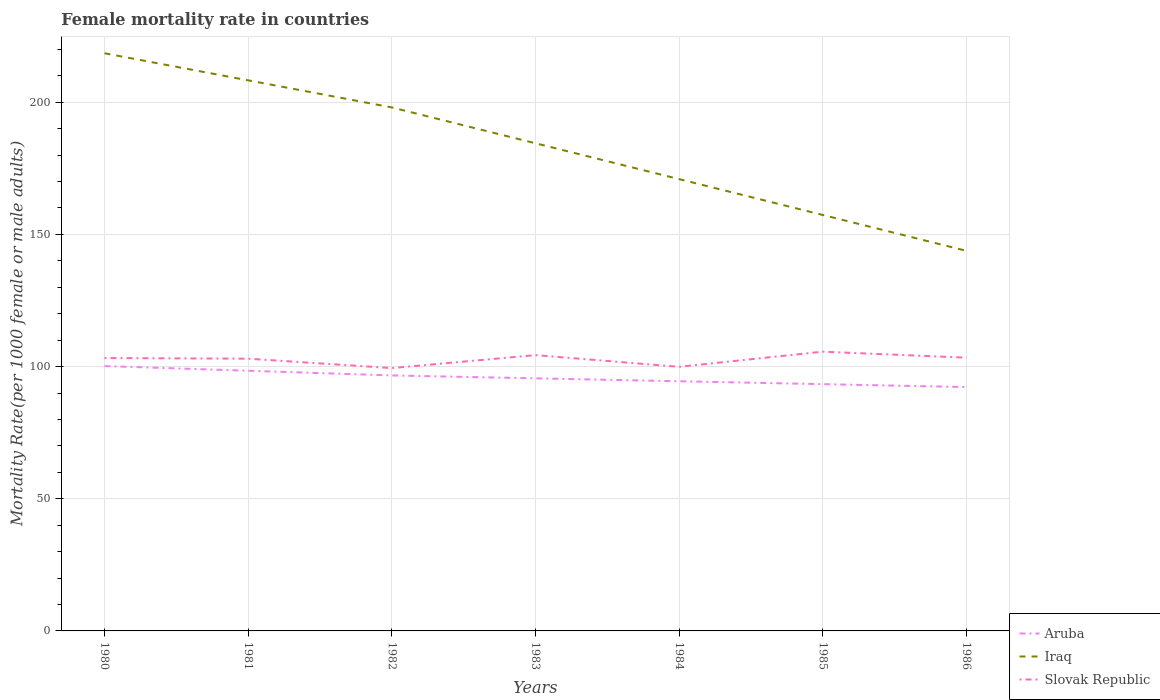How many different coloured lines are there?
Offer a terse response. 3. Does the line corresponding to Aruba intersect with the line corresponding to Slovak Republic?
Ensure brevity in your answer.  No. Across all years, what is the maximum female mortality rate in Iraq?
Offer a very short reply. 143.8. What is the total female mortality rate in Slovak Republic in the graph?
Provide a succinct answer. -0.48. What is the difference between the highest and the second highest female mortality rate in Iraq?
Your answer should be compact. 74.74. What is the difference between the highest and the lowest female mortality rate in Aruba?
Your answer should be compact. 3. What is the difference between two consecutive major ticks on the Y-axis?
Your response must be concise. 50. Are the values on the major ticks of Y-axis written in scientific E-notation?
Your response must be concise. No. Does the graph contain grids?
Offer a terse response. Yes. Where does the legend appear in the graph?
Keep it short and to the point. Bottom right. What is the title of the graph?
Offer a terse response. Female mortality rate in countries. Does "Iraq" appear as one of the legend labels in the graph?
Your answer should be very brief. Yes. What is the label or title of the Y-axis?
Your answer should be compact. Mortality Rate(per 1000 female or male adults). What is the Mortality Rate(per 1000 female or male adults) of Aruba in 1980?
Offer a terse response. 100.2. What is the Mortality Rate(per 1000 female or male adults) of Iraq in 1980?
Make the answer very short. 218.54. What is the Mortality Rate(per 1000 female or male adults) in Slovak Republic in 1980?
Offer a very short reply. 103.24. What is the Mortality Rate(per 1000 female or male adults) of Aruba in 1981?
Your response must be concise. 98.43. What is the Mortality Rate(per 1000 female or male adults) of Iraq in 1981?
Offer a terse response. 208.29. What is the Mortality Rate(per 1000 female or male adults) in Slovak Republic in 1981?
Provide a short and direct response. 102.99. What is the Mortality Rate(per 1000 female or male adults) in Aruba in 1982?
Give a very brief answer. 96.66. What is the Mortality Rate(per 1000 female or male adults) of Iraq in 1982?
Your answer should be very brief. 198.05. What is the Mortality Rate(per 1000 female or male adults) of Slovak Republic in 1982?
Your answer should be very brief. 99.44. What is the Mortality Rate(per 1000 female or male adults) of Aruba in 1983?
Your response must be concise. 95.56. What is the Mortality Rate(per 1000 female or male adults) in Iraq in 1983?
Offer a terse response. 184.49. What is the Mortality Rate(per 1000 female or male adults) in Slovak Republic in 1983?
Provide a succinct answer. 104.34. What is the Mortality Rate(per 1000 female or male adults) of Aruba in 1984?
Ensure brevity in your answer.  94.46. What is the Mortality Rate(per 1000 female or male adults) in Iraq in 1984?
Your response must be concise. 170.93. What is the Mortality Rate(per 1000 female or male adults) of Slovak Republic in 1984?
Provide a short and direct response. 99.92. What is the Mortality Rate(per 1000 female or male adults) in Aruba in 1985?
Your response must be concise. 93.36. What is the Mortality Rate(per 1000 female or male adults) of Iraq in 1985?
Give a very brief answer. 157.36. What is the Mortality Rate(per 1000 female or male adults) of Slovak Republic in 1985?
Keep it short and to the point. 105.65. What is the Mortality Rate(per 1000 female or male adults) of Aruba in 1986?
Provide a succinct answer. 92.25. What is the Mortality Rate(per 1000 female or male adults) of Iraq in 1986?
Give a very brief answer. 143.8. What is the Mortality Rate(per 1000 female or male adults) in Slovak Republic in 1986?
Offer a very short reply. 103.38. Across all years, what is the maximum Mortality Rate(per 1000 female or male adults) in Aruba?
Give a very brief answer. 100.2. Across all years, what is the maximum Mortality Rate(per 1000 female or male adults) of Iraq?
Your answer should be compact. 218.54. Across all years, what is the maximum Mortality Rate(per 1000 female or male adults) of Slovak Republic?
Provide a short and direct response. 105.65. Across all years, what is the minimum Mortality Rate(per 1000 female or male adults) of Aruba?
Offer a very short reply. 92.25. Across all years, what is the minimum Mortality Rate(per 1000 female or male adults) of Iraq?
Ensure brevity in your answer.  143.8. Across all years, what is the minimum Mortality Rate(per 1000 female or male adults) of Slovak Republic?
Make the answer very short. 99.44. What is the total Mortality Rate(per 1000 female or male adults) in Aruba in the graph?
Provide a short and direct response. 670.9. What is the total Mortality Rate(per 1000 female or male adults) in Iraq in the graph?
Offer a very short reply. 1281.46. What is the total Mortality Rate(per 1000 female or male adults) in Slovak Republic in the graph?
Offer a terse response. 718.95. What is the difference between the Mortality Rate(per 1000 female or male adults) in Aruba in 1980 and that in 1981?
Ensure brevity in your answer.  1.77. What is the difference between the Mortality Rate(per 1000 female or male adults) in Iraq in 1980 and that in 1981?
Offer a very short reply. 10.24. What is the difference between the Mortality Rate(per 1000 female or male adults) in Slovak Republic in 1980 and that in 1981?
Make the answer very short. 0.25. What is the difference between the Mortality Rate(per 1000 female or male adults) of Aruba in 1980 and that in 1982?
Provide a short and direct response. 3.54. What is the difference between the Mortality Rate(per 1000 female or male adults) in Iraq in 1980 and that in 1982?
Ensure brevity in your answer.  20.49. What is the difference between the Mortality Rate(per 1000 female or male adults) of Slovak Republic in 1980 and that in 1982?
Offer a very short reply. 3.8. What is the difference between the Mortality Rate(per 1000 female or male adults) of Aruba in 1980 and that in 1983?
Your response must be concise. 4.64. What is the difference between the Mortality Rate(per 1000 female or male adults) in Iraq in 1980 and that in 1983?
Ensure brevity in your answer.  34.05. What is the difference between the Mortality Rate(per 1000 female or male adults) in Slovak Republic in 1980 and that in 1983?
Your response must be concise. -1.1. What is the difference between the Mortality Rate(per 1000 female or male adults) of Aruba in 1980 and that in 1984?
Provide a short and direct response. 5.74. What is the difference between the Mortality Rate(per 1000 female or male adults) in Iraq in 1980 and that in 1984?
Offer a very short reply. 47.61. What is the difference between the Mortality Rate(per 1000 female or male adults) in Slovak Republic in 1980 and that in 1984?
Provide a succinct answer. 3.32. What is the difference between the Mortality Rate(per 1000 female or male adults) in Aruba in 1980 and that in 1985?
Give a very brief answer. 6.84. What is the difference between the Mortality Rate(per 1000 female or male adults) of Iraq in 1980 and that in 1985?
Ensure brevity in your answer.  61.17. What is the difference between the Mortality Rate(per 1000 female or male adults) in Slovak Republic in 1980 and that in 1985?
Offer a terse response. -2.41. What is the difference between the Mortality Rate(per 1000 female or male adults) in Aruba in 1980 and that in 1986?
Provide a succinct answer. 7.94. What is the difference between the Mortality Rate(per 1000 female or male adults) in Iraq in 1980 and that in 1986?
Offer a terse response. 74.74. What is the difference between the Mortality Rate(per 1000 female or male adults) in Slovak Republic in 1980 and that in 1986?
Provide a succinct answer. -0.14. What is the difference between the Mortality Rate(per 1000 female or male adults) in Aruba in 1981 and that in 1982?
Provide a short and direct response. 1.77. What is the difference between the Mortality Rate(per 1000 female or male adults) in Iraq in 1981 and that in 1982?
Ensure brevity in your answer.  10.24. What is the difference between the Mortality Rate(per 1000 female or male adults) in Slovak Republic in 1981 and that in 1982?
Provide a succinct answer. 3.56. What is the difference between the Mortality Rate(per 1000 female or male adults) of Aruba in 1981 and that in 1983?
Give a very brief answer. 2.87. What is the difference between the Mortality Rate(per 1000 female or male adults) of Iraq in 1981 and that in 1983?
Your response must be concise. 23.81. What is the difference between the Mortality Rate(per 1000 female or male adults) in Slovak Republic in 1981 and that in 1983?
Make the answer very short. -1.35. What is the difference between the Mortality Rate(per 1000 female or male adults) in Aruba in 1981 and that in 1984?
Provide a short and direct response. 3.97. What is the difference between the Mortality Rate(per 1000 female or male adults) in Iraq in 1981 and that in 1984?
Provide a short and direct response. 37.37. What is the difference between the Mortality Rate(per 1000 female or male adults) in Slovak Republic in 1981 and that in 1984?
Make the answer very short. 3.07. What is the difference between the Mortality Rate(per 1000 female or male adults) in Aruba in 1981 and that in 1985?
Offer a very short reply. 5.07. What is the difference between the Mortality Rate(per 1000 female or male adults) of Iraq in 1981 and that in 1985?
Your answer should be compact. 50.93. What is the difference between the Mortality Rate(per 1000 female or male adults) of Slovak Republic in 1981 and that in 1985?
Offer a very short reply. -2.66. What is the difference between the Mortality Rate(per 1000 female or male adults) in Aruba in 1981 and that in 1986?
Make the answer very short. 6.17. What is the difference between the Mortality Rate(per 1000 female or male adults) of Iraq in 1981 and that in 1986?
Your answer should be very brief. 64.49. What is the difference between the Mortality Rate(per 1000 female or male adults) of Slovak Republic in 1981 and that in 1986?
Keep it short and to the point. -0.39. What is the difference between the Mortality Rate(per 1000 female or male adults) of Aruba in 1982 and that in 1983?
Your answer should be very brief. 1.1. What is the difference between the Mortality Rate(per 1000 female or male adults) of Iraq in 1982 and that in 1983?
Make the answer very short. 13.56. What is the difference between the Mortality Rate(per 1000 female or male adults) of Slovak Republic in 1982 and that in 1983?
Your answer should be very brief. -4.9. What is the difference between the Mortality Rate(per 1000 female or male adults) of Aruba in 1982 and that in 1984?
Give a very brief answer. 2.2. What is the difference between the Mortality Rate(per 1000 female or male adults) of Iraq in 1982 and that in 1984?
Offer a very short reply. 27.12. What is the difference between the Mortality Rate(per 1000 female or male adults) in Slovak Republic in 1982 and that in 1984?
Offer a terse response. -0.48. What is the difference between the Mortality Rate(per 1000 female or male adults) of Aruba in 1982 and that in 1985?
Your answer should be very brief. 3.3. What is the difference between the Mortality Rate(per 1000 female or male adults) of Iraq in 1982 and that in 1985?
Your answer should be very brief. 40.69. What is the difference between the Mortality Rate(per 1000 female or male adults) in Slovak Republic in 1982 and that in 1985?
Make the answer very short. -6.21. What is the difference between the Mortality Rate(per 1000 female or male adults) in Aruba in 1982 and that in 1986?
Give a very brief answer. 4.4. What is the difference between the Mortality Rate(per 1000 female or male adults) in Iraq in 1982 and that in 1986?
Your answer should be very brief. 54.25. What is the difference between the Mortality Rate(per 1000 female or male adults) of Slovak Republic in 1982 and that in 1986?
Your answer should be compact. -3.94. What is the difference between the Mortality Rate(per 1000 female or male adults) of Iraq in 1983 and that in 1984?
Offer a terse response. 13.56. What is the difference between the Mortality Rate(per 1000 female or male adults) of Slovak Republic in 1983 and that in 1984?
Offer a very short reply. 4.42. What is the difference between the Mortality Rate(per 1000 female or male adults) of Aruba in 1983 and that in 1985?
Provide a short and direct response. 2.2. What is the difference between the Mortality Rate(per 1000 female or male adults) of Iraq in 1983 and that in 1985?
Give a very brief answer. 27.12. What is the difference between the Mortality Rate(per 1000 female or male adults) of Slovak Republic in 1983 and that in 1985?
Ensure brevity in your answer.  -1.31. What is the difference between the Mortality Rate(per 1000 female or male adults) in Aruba in 1983 and that in 1986?
Ensure brevity in your answer.  3.3. What is the difference between the Mortality Rate(per 1000 female or male adults) in Iraq in 1983 and that in 1986?
Make the answer very short. 40.69. What is the difference between the Mortality Rate(per 1000 female or male adults) of Aruba in 1984 and that in 1985?
Your answer should be compact. 1.1. What is the difference between the Mortality Rate(per 1000 female or male adults) of Iraq in 1984 and that in 1985?
Your answer should be very brief. 13.56. What is the difference between the Mortality Rate(per 1000 female or male adults) in Slovak Republic in 1984 and that in 1985?
Give a very brief answer. -5.73. What is the difference between the Mortality Rate(per 1000 female or male adults) in Aruba in 1984 and that in 1986?
Provide a short and direct response. 2.2. What is the difference between the Mortality Rate(per 1000 female or male adults) of Iraq in 1984 and that in 1986?
Your response must be concise. 27.12. What is the difference between the Mortality Rate(per 1000 female or male adults) of Slovak Republic in 1984 and that in 1986?
Your answer should be very brief. -3.46. What is the difference between the Mortality Rate(per 1000 female or male adults) of Aruba in 1985 and that in 1986?
Offer a very short reply. 1.1. What is the difference between the Mortality Rate(per 1000 female or male adults) of Iraq in 1985 and that in 1986?
Provide a short and direct response. 13.56. What is the difference between the Mortality Rate(per 1000 female or male adults) of Slovak Republic in 1985 and that in 1986?
Provide a short and direct response. 2.27. What is the difference between the Mortality Rate(per 1000 female or male adults) of Aruba in 1980 and the Mortality Rate(per 1000 female or male adults) of Iraq in 1981?
Offer a very short reply. -108.1. What is the difference between the Mortality Rate(per 1000 female or male adults) of Aruba in 1980 and the Mortality Rate(per 1000 female or male adults) of Slovak Republic in 1981?
Ensure brevity in your answer.  -2.79. What is the difference between the Mortality Rate(per 1000 female or male adults) of Iraq in 1980 and the Mortality Rate(per 1000 female or male adults) of Slovak Republic in 1981?
Make the answer very short. 115.55. What is the difference between the Mortality Rate(per 1000 female or male adults) of Aruba in 1980 and the Mortality Rate(per 1000 female or male adults) of Iraq in 1982?
Your response must be concise. -97.85. What is the difference between the Mortality Rate(per 1000 female or male adults) in Aruba in 1980 and the Mortality Rate(per 1000 female or male adults) in Slovak Republic in 1982?
Provide a short and direct response. 0.76. What is the difference between the Mortality Rate(per 1000 female or male adults) of Iraq in 1980 and the Mortality Rate(per 1000 female or male adults) of Slovak Republic in 1982?
Your answer should be compact. 119.1. What is the difference between the Mortality Rate(per 1000 female or male adults) of Aruba in 1980 and the Mortality Rate(per 1000 female or male adults) of Iraq in 1983?
Your response must be concise. -84.29. What is the difference between the Mortality Rate(per 1000 female or male adults) of Aruba in 1980 and the Mortality Rate(per 1000 female or male adults) of Slovak Republic in 1983?
Your response must be concise. -4.14. What is the difference between the Mortality Rate(per 1000 female or male adults) in Iraq in 1980 and the Mortality Rate(per 1000 female or male adults) in Slovak Republic in 1983?
Offer a terse response. 114.2. What is the difference between the Mortality Rate(per 1000 female or male adults) in Aruba in 1980 and the Mortality Rate(per 1000 female or male adults) in Iraq in 1984?
Your response must be concise. -70.73. What is the difference between the Mortality Rate(per 1000 female or male adults) in Aruba in 1980 and the Mortality Rate(per 1000 female or male adults) in Slovak Republic in 1984?
Provide a succinct answer. 0.28. What is the difference between the Mortality Rate(per 1000 female or male adults) in Iraq in 1980 and the Mortality Rate(per 1000 female or male adults) in Slovak Republic in 1984?
Offer a very short reply. 118.62. What is the difference between the Mortality Rate(per 1000 female or male adults) of Aruba in 1980 and the Mortality Rate(per 1000 female or male adults) of Iraq in 1985?
Ensure brevity in your answer.  -57.17. What is the difference between the Mortality Rate(per 1000 female or male adults) of Aruba in 1980 and the Mortality Rate(per 1000 female or male adults) of Slovak Republic in 1985?
Your response must be concise. -5.45. What is the difference between the Mortality Rate(per 1000 female or male adults) of Iraq in 1980 and the Mortality Rate(per 1000 female or male adults) of Slovak Republic in 1985?
Provide a short and direct response. 112.89. What is the difference between the Mortality Rate(per 1000 female or male adults) in Aruba in 1980 and the Mortality Rate(per 1000 female or male adults) in Iraq in 1986?
Provide a short and direct response. -43.6. What is the difference between the Mortality Rate(per 1000 female or male adults) in Aruba in 1980 and the Mortality Rate(per 1000 female or male adults) in Slovak Republic in 1986?
Offer a very short reply. -3.18. What is the difference between the Mortality Rate(per 1000 female or male adults) of Iraq in 1980 and the Mortality Rate(per 1000 female or male adults) of Slovak Republic in 1986?
Offer a very short reply. 115.16. What is the difference between the Mortality Rate(per 1000 female or male adults) of Aruba in 1981 and the Mortality Rate(per 1000 female or male adults) of Iraq in 1982?
Offer a terse response. -99.62. What is the difference between the Mortality Rate(per 1000 female or male adults) in Aruba in 1981 and the Mortality Rate(per 1000 female or male adults) in Slovak Republic in 1982?
Your answer should be compact. -1.01. What is the difference between the Mortality Rate(per 1000 female or male adults) in Iraq in 1981 and the Mortality Rate(per 1000 female or male adults) in Slovak Republic in 1982?
Offer a terse response. 108.86. What is the difference between the Mortality Rate(per 1000 female or male adults) of Aruba in 1981 and the Mortality Rate(per 1000 female or male adults) of Iraq in 1983?
Provide a succinct answer. -86.06. What is the difference between the Mortality Rate(per 1000 female or male adults) of Aruba in 1981 and the Mortality Rate(per 1000 female or male adults) of Slovak Republic in 1983?
Give a very brief answer. -5.91. What is the difference between the Mortality Rate(per 1000 female or male adults) of Iraq in 1981 and the Mortality Rate(per 1000 female or male adults) of Slovak Republic in 1983?
Give a very brief answer. 103.95. What is the difference between the Mortality Rate(per 1000 female or male adults) of Aruba in 1981 and the Mortality Rate(per 1000 female or male adults) of Iraq in 1984?
Offer a terse response. -72.5. What is the difference between the Mortality Rate(per 1000 female or male adults) in Aruba in 1981 and the Mortality Rate(per 1000 female or male adults) in Slovak Republic in 1984?
Offer a very short reply. -1.49. What is the difference between the Mortality Rate(per 1000 female or male adults) in Iraq in 1981 and the Mortality Rate(per 1000 female or male adults) in Slovak Republic in 1984?
Provide a short and direct response. 108.38. What is the difference between the Mortality Rate(per 1000 female or male adults) of Aruba in 1981 and the Mortality Rate(per 1000 female or male adults) of Iraq in 1985?
Ensure brevity in your answer.  -58.94. What is the difference between the Mortality Rate(per 1000 female or male adults) of Aruba in 1981 and the Mortality Rate(per 1000 female or male adults) of Slovak Republic in 1985?
Provide a succinct answer. -7.22. What is the difference between the Mortality Rate(per 1000 female or male adults) of Iraq in 1981 and the Mortality Rate(per 1000 female or male adults) of Slovak Republic in 1985?
Provide a succinct answer. 102.65. What is the difference between the Mortality Rate(per 1000 female or male adults) of Aruba in 1981 and the Mortality Rate(per 1000 female or male adults) of Iraq in 1986?
Provide a short and direct response. -45.37. What is the difference between the Mortality Rate(per 1000 female or male adults) in Aruba in 1981 and the Mortality Rate(per 1000 female or male adults) in Slovak Republic in 1986?
Your answer should be very brief. -4.95. What is the difference between the Mortality Rate(per 1000 female or male adults) of Iraq in 1981 and the Mortality Rate(per 1000 female or male adults) of Slovak Republic in 1986?
Give a very brief answer. 104.92. What is the difference between the Mortality Rate(per 1000 female or male adults) in Aruba in 1982 and the Mortality Rate(per 1000 female or male adults) in Iraq in 1983?
Your answer should be compact. -87.83. What is the difference between the Mortality Rate(per 1000 female or male adults) in Aruba in 1982 and the Mortality Rate(per 1000 female or male adults) in Slovak Republic in 1983?
Your response must be concise. -7.68. What is the difference between the Mortality Rate(per 1000 female or male adults) in Iraq in 1982 and the Mortality Rate(per 1000 female or male adults) in Slovak Republic in 1983?
Provide a short and direct response. 93.71. What is the difference between the Mortality Rate(per 1000 female or male adults) of Aruba in 1982 and the Mortality Rate(per 1000 female or male adults) of Iraq in 1984?
Your response must be concise. -74.27. What is the difference between the Mortality Rate(per 1000 female or male adults) of Aruba in 1982 and the Mortality Rate(per 1000 female or male adults) of Slovak Republic in 1984?
Give a very brief answer. -3.26. What is the difference between the Mortality Rate(per 1000 female or male adults) of Iraq in 1982 and the Mortality Rate(per 1000 female or male adults) of Slovak Republic in 1984?
Your response must be concise. 98.13. What is the difference between the Mortality Rate(per 1000 female or male adults) of Aruba in 1982 and the Mortality Rate(per 1000 female or male adults) of Iraq in 1985?
Keep it short and to the point. -60.71. What is the difference between the Mortality Rate(per 1000 female or male adults) in Aruba in 1982 and the Mortality Rate(per 1000 female or male adults) in Slovak Republic in 1985?
Offer a very short reply. -8.99. What is the difference between the Mortality Rate(per 1000 female or male adults) of Iraq in 1982 and the Mortality Rate(per 1000 female or male adults) of Slovak Republic in 1985?
Keep it short and to the point. 92.4. What is the difference between the Mortality Rate(per 1000 female or male adults) of Aruba in 1982 and the Mortality Rate(per 1000 female or male adults) of Iraq in 1986?
Your answer should be compact. -47.15. What is the difference between the Mortality Rate(per 1000 female or male adults) in Aruba in 1982 and the Mortality Rate(per 1000 female or male adults) in Slovak Republic in 1986?
Offer a very short reply. -6.72. What is the difference between the Mortality Rate(per 1000 female or male adults) in Iraq in 1982 and the Mortality Rate(per 1000 female or male adults) in Slovak Republic in 1986?
Your answer should be very brief. 94.67. What is the difference between the Mortality Rate(per 1000 female or male adults) of Aruba in 1983 and the Mortality Rate(per 1000 female or male adults) of Iraq in 1984?
Make the answer very short. -75.37. What is the difference between the Mortality Rate(per 1000 female or male adults) of Aruba in 1983 and the Mortality Rate(per 1000 female or male adults) of Slovak Republic in 1984?
Provide a succinct answer. -4.36. What is the difference between the Mortality Rate(per 1000 female or male adults) of Iraq in 1983 and the Mortality Rate(per 1000 female or male adults) of Slovak Republic in 1984?
Your response must be concise. 84.57. What is the difference between the Mortality Rate(per 1000 female or male adults) in Aruba in 1983 and the Mortality Rate(per 1000 female or male adults) in Iraq in 1985?
Your response must be concise. -61.81. What is the difference between the Mortality Rate(per 1000 female or male adults) of Aruba in 1983 and the Mortality Rate(per 1000 female or male adults) of Slovak Republic in 1985?
Your answer should be compact. -10.09. What is the difference between the Mortality Rate(per 1000 female or male adults) in Iraq in 1983 and the Mortality Rate(per 1000 female or male adults) in Slovak Republic in 1985?
Give a very brief answer. 78.84. What is the difference between the Mortality Rate(per 1000 female or male adults) in Aruba in 1983 and the Mortality Rate(per 1000 female or male adults) in Iraq in 1986?
Ensure brevity in your answer.  -48.25. What is the difference between the Mortality Rate(per 1000 female or male adults) of Aruba in 1983 and the Mortality Rate(per 1000 female or male adults) of Slovak Republic in 1986?
Your answer should be compact. -7.82. What is the difference between the Mortality Rate(per 1000 female or male adults) in Iraq in 1983 and the Mortality Rate(per 1000 female or male adults) in Slovak Republic in 1986?
Offer a very short reply. 81.11. What is the difference between the Mortality Rate(per 1000 female or male adults) of Aruba in 1984 and the Mortality Rate(per 1000 female or male adults) of Iraq in 1985?
Make the answer very short. -62.91. What is the difference between the Mortality Rate(per 1000 female or male adults) in Aruba in 1984 and the Mortality Rate(per 1000 female or male adults) in Slovak Republic in 1985?
Ensure brevity in your answer.  -11.19. What is the difference between the Mortality Rate(per 1000 female or male adults) in Iraq in 1984 and the Mortality Rate(per 1000 female or male adults) in Slovak Republic in 1985?
Your response must be concise. 65.28. What is the difference between the Mortality Rate(per 1000 female or male adults) of Aruba in 1984 and the Mortality Rate(per 1000 female or male adults) of Iraq in 1986?
Your answer should be very brief. -49.35. What is the difference between the Mortality Rate(per 1000 female or male adults) in Aruba in 1984 and the Mortality Rate(per 1000 female or male adults) in Slovak Republic in 1986?
Your answer should be very brief. -8.92. What is the difference between the Mortality Rate(per 1000 female or male adults) of Iraq in 1984 and the Mortality Rate(per 1000 female or male adults) of Slovak Republic in 1986?
Ensure brevity in your answer.  67.55. What is the difference between the Mortality Rate(per 1000 female or male adults) of Aruba in 1985 and the Mortality Rate(per 1000 female or male adults) of Iraq in 1986?
Provide a short and direct response. -50.45. What is the difference between the Mortality Rate(per 1000 female or male adults) in Aruba in 1985 and the Mortality Rate(per 1000 female or male adults) in Slovak Republic in 1986?
Keep it short and to the point. -10.02. What is the difference between the Mortality Rate(per 1000 female or male adults) in Iraq in 1985 and the Mortality Rate(per 1000 female or male adults) in Slovak Republic in 1986?
Provide a succinct answer. 53.99. What is the average Mortality Rate(per 1000 female or male adults) of Aruba per year?
Provide a succinct answer. 95.84. What is the average Mortality Rate(per 1000 female or male adults) of Iraq per year?
Your answer should be compact. 183.07. What is the average Mortality Rate(per 1000 female or male adults) of Slovak Republic per year?
Provide a short and direct response. 102.71. In the year 1980, what is the difference between the Mortality Rate(per 1000 female or male adults) in Aruba and Mortality Rate(per 1000 female or male adults) in Iraq?
Your response must be concise. -118.34. In the year 1980, what is the difference between the Mortality Rate(per 1000 female or male adults) in Aruba and Mortality Rate(per 1000 female or male adults) in Slovak Republic?
Ensure brevity in your answer.  -3.04. In the year 1980, what is the difference between the Mortality Rate(per 1000 female or male adults) in Iraq and Mortality Rate(per 1000 female or male adults) in Slovak Republic?
Your response must be concise. 115.3. In the year 1981, what is the difference between the Mortality Rate(per 1000 female or male adults) of Aruba and Mortality Rate(per 1000 female or male adults) of Iraq?
Provide a succinct answer. -109.87. In the year 1981, what is the difference between the Mortality Rate(per 1000 female or male adults) of Aruba and Mortality Rate(per 1000 female or male adults) of Slovak Republic?
Your response must be concise. -4.56. In the year 1981, what is the difference between the Mortality Rate(per 1000 female or male adults) in Iraq and Mortality Rate(per 1000 female or male adults) in Slovak Republic?
Ensure brevity in your answer.  105.3. In the year 1982, what is the difference between the Mortality Rate(per 1000 female or male adults) of Aruba and Mortality Rate(per 1000 female or male adults) of Iraq?
Provide a succinct answer. -101.39. In the year 1982, what is the difference between the Mortality Rate(per 1000 female or male adults) of Aruba and Mortality Rate(per 1000 female or male adults) of Slovak Republic?
Your response must be concise. -2.78. In the year 1982, what is the difference between the Mortality Rate(per 1000 female or male adults) of Iraq and Mortality Rate(per 1000 female or male adults) of Slovak Republic?
Make the answer very short. 98.61. In the year 1983, what is the difference between the Mortality Rate(per 1000 female or male adults) of Aruba and Mortality Rate(per 1000 female or male adults) of Iraq?
Provide a short and direct response. -88.93. In the year 1983, what is the difference between the Mortality Rate(per 1000 female or male adults) of Aruba and Mortality Rate(per 1000 female or male adults) of Slovak Republic?
Give a very brief answer. -8.78. In the year 1983, what is the difference between the Mortality Rate(per 1000 female or male adults) in Iraq and Mortality Rate(per 1000 female or male adults) in Slovak Republic?
Offer a terse response. 80.15. In the year 1984, what is the difference between the Mortality Rate(per 1000 female or male adults) in Aruba and Mortality Rate(per 1000 female or male adults) in Iraq?
Your response must be concise. -76.47. In the year 1984, what is the difference between the Mortality Rate(per 1000 female or male adults) in Aruba and Mortality Rate(per 1000 female or male adults) in Slovak Republic?
Keep it short and to the point. -5.46. In the year 1984, what is the difference between the Mortality Rate(per 1000 female or male adults) in Iraq and Mortality Rate(per 1000 female or male adults) in Slovak Republic?
Keep it short and to the point. 71.01. In the year 1985, what is the difference between the Mortality Rate(per 1000 female or male adults) in Aruba and Mortality Rate(per 1000 female or male adults) in Iraq?
Provide a short and direct response. -64.01. In the year 1985, what is the difference between the Mortality Rate(per 1000 female or male adults) in Aruba and Mortality Rate(per 1000 female or male adults) in Slovak Republic?
Your answer should be compact. -12.29. In the year 1985, what is the difference between the Mortality Rate(per 1000 female or male adults) in Iraq and Mortality Rate(per 1000 female or male adults) in Slovak Republic?
Provide a short and direct response. 51.72. In the year 1986, what is the difference between the Mortality Rate(per 1000 female or male adults) in Aruba and Mortality Rate(per 1000 female or male adults) in Iraq?
Your answer should be very brief. -51.55. In the year 1986, what is the difference between the Mortality Rate(per 1000 female or male adults) of Aruba and Mortality Rate(per 1000 female or male adults) of Slovak Republic?
Your response must be concise. -11.12. In the year 1986, what is the difference between the Mortality Rate(per 1000 female or male adults) in Iraq and Mortality Rate(per 1000 female or male adults) in Slovak Republic?
Give a very brief answer. 40.43. What is the ratio of the Mortality Rate(per 1000 female or male adults) of Aruba in 1980 to that in 1981?
Your answer should be compact. 1.02. What is the ratio of the Mortality Rate(per 1000 female or male adults) in Iraq in 1980 to that in 1981?
Provide a short and direct response. 1.05. What is the ratio of the Mortality Rate(per 1000 female or male adults) of Aruba in 1980 to that in 1982?
Your answer should be very brief. 1.04. What is the ratio of the Mortality Rate(per 1000 female or male adults) in Iraq in 1980 to that in 1982?
Your answer should be compact. 1.1. What is the ratio of the Mortality Rate(per 1000 female or male adults) of Slovak Republic in 1980 to that in 1982?
Offer a terse response. 1.04. What is the ratio of the Mortality Rate(per 1000 female or male adults) in Aruba in 1980 to that in 1983?
Your answer should be very brief. 1.05. What is the ratio of the Mortality Rate(per 1000 female or male adults) of Iraq in 1980 to that in 1983?
Keep it short and to the point. 1.18. What is the ratio of the Mortality Rate(per 1000 female or male adults) in Aruba in 1980 to that in 1984?
Provide a short and direct response. 1.06. What is the ratio of the Mortality Rate(per 1000 female or male adults) of Iraq in 1980 to that in 1984?
Your response must be concise. 1.28. What is the ratio of the Mortality Rate(per 1000 female or male adults) of Slovak Republic in 1980 to that in 1984?
Provide a succinct answer. 1.03. What is the ratio of the Mortality Rate(per 1000 female or male adults) of Aruba in 1980 to that in 1985?
Offer a terse response. 1.07. What is the ratio of the Mortality Rate(per 1000 female or male adults) of Iraq in 1980 to that in 1985?
Offer a terse response. 1.39. What is the ratio of the Mortality Rate(per 1000 female or male adults) in Slovak Republic in 1980 to that in 1985?
Ensure brevity in your answer.  0.98. What is the ratio of the Mortality Rate(per 1000 female or male adults) in Aruba in 1980 to that in 1986?
Make the answer very short. 1.09. What is the ratio of the Mortality Rate(per 1000 female or male adults) in Iraq in 1980 to that in 1986?
Offer a terse response. 1.52. What is the ratio of the Mortality Rate(per 1000 female or male adults) of Slovak Republic in 1980 to that in 1986?
Make the answer very short. 1. What is the ratio of the Mortality Rate(per 1000 female or male adults) in Aruba in 1981 to that in 1982?
Your response must be concise. 1.02. What is the ratio of the Mortality Rate(per 1000 female or male adults) in Iraq in 1981 to that in 1982?
Make the answer very short. 1.05. What is the ratio of the Mortality Rate(per 1000 female or male adults) of Slovak Republic in 1981 to that in 1982?
Offer a very short reply. 1.04. What is the ratio of the Mortality Rate(per 1000 female or male adults) of Aruba in 1981 to that in 1983?
Make the answer very short. 1.03. What is the ratio of the Mortality Rate(per 1000 female or male adults) in Iraq in 1981 to that in 1983?
Ensure brevity in your answer.  1.13. What is the ratio of the Mortality Rate(per 1000 female or male adults) of Slovak Republic in 1981 to that in 1983?
Your answer should be very brief. 0.99. What is the ratio of the Mortality Rate(per 1000 female or male adults) of Aruba in 1981 to that in 1984?
Offer a very short reply. 1.04. What is the ratio of the Mortality Rate(per 1000 female or male adults) in Iraq in 1981 to that in 1984?
Offer a terse response. 1.22. What is the ratio of the Mortality Rate(per 1000 female or male adults) in Slovak Republic in 1981 to that in 1984?
Offer a terse response. 1.03. What is the ratio of the Mortality Rate(per 1000 female or male adults) of Aruba in 1981 to that in 1985?
Provide a short and direct response. 1.05. What is the ratio of the Mortality Rate(per 1000 female or male adults) of Iraq in 1981 to that in 1985?
Make the answer very short. 1.32. What is the ratio of the Mortality Rate(per 1000 female or male adults) in Slovak Republic in 1981 to that in 1985?
Provide a succinct answer. 0.97. What is the ratio of the Mortality Rate(per 1000 female or male adults) of Aruba in 1981 to that in 1986?
Provide a short and direct response. 1.07. What is the ratio of the Mortality Rate(per 1000 female or male adults) in Iraq in 1981 to that in 1986?
Your answer should be very brief. 1.45. What is the ratio of the Mortality Rate(per 1000 female or male adults) of Slovak Republic in 1981 to that in 1986?
Your answer should be very brief. 1. What is the ratio of the Mortality Rate(per 1000 female or male adults) in Aruba in 1982 to that in 1983?
Provide a short and direct response. 1.01. What is the ratio of the Mortality Rate(per 1000 female or male adults) of Iraq in 1982 to that in 1983?
Provide a short and direct response. 1.07. What is the ratio of the Mortality Rate(per 1000 female or male adults) of Slovak Republic in 1982 to that in 1983?
Your response must be concise. 0.95. What is the ratio of the Mortality Rate(per 1000 female or male adults) of Aruba in 1982 to that in 1984?
Give a very brief answer. 1.02. What is the ratio of the Mortality Rate(per 1000 female or male adults) of Iraq in 1982 to that in 1984?
Give a very brief answer. 1.16. What is the ratio of the Mortality Rate(per 1000 female or male adults) of Aruba in 1982 to that in 1985?
Your answer should be compact. 1.04. What is the ratio of the Mortality Rate(per 1000 female or male adults) of Iraq in 1982 to that in 1985?
Give a very brief answer. 1.26. What is the ratio of the Mortality Rate(per 1000 female or male adults) of Slovak Republic in 1982 to that in 1985?
Make the answer very short. 0.94. What is the ratio of the Mortality Rate(per 1000 female or male adults) in Aruba in 1982 to that in 1986?
Your answer should be compact. 1.05. What is the ratio of the Mortality Rate(per 1000 female or male adults) in Iraq in 1982 to that in 1986?
Your answer should be very brief. 1.38. What is the ratio of the Mortality Rate(per 1000 female or male adults) in Slovak Republic in 1982 to that in 1986?
Offer a very short reply. 0.96. What is the ratio of the Mortality Rate(per 1000 female or male adults) in Aruba in 1983 to that in 1984?
Provide a succinct answer. 1.01. What is the ratio of the Mortality Rate(per 1000 female or male adults) of Iraq in 1983 to that in 1984?
Offer a terse response. 1.08. What is the ratio of the Mortality Rate(per 1000 female or male adults) in Slovak Republic in 1983 to that in 1984?
Provide a short and direct response. 1.04. What is the ratio of the Mortality Rate(per 1000 female or male adults) in Aruba in 1983 to that in 1985?
Keep it short and to the point. 1.02. What is the ratio of the Mortality Rate(per 1000 female or male adults) in Iraq in 1983 to that in 1985?
Give a very brief answer. 1.17. What is the ratio of the Mortality Rate(per 1000 female or male adults) of Slovak Republic in 1983 to that in 1985?
Give a very brief answer. 0.99. What is the ratio of the Mortality Rate(per 1000 female or male adults) in Aruba in 1983 to that in 1986?
Make the answer very short. 1.04. What is the ratio of the Mortality Rate(per 1000 female or male adults) of Iraq in 1983 to that in 1986?
Your response must be concise. 1.28. What is the ratio of the Mortality Rate(per 1000 female or male adults) of Slovak Republic in 1983 to that in 1986?
Give a very brief answer. 1.01. What is the ratio of the Mortality Rate(per 1000 female or male adults) in Aruba in 1984 to that in 1985?
Give a very brief answer. 1.01. What is the ratio of the Mortality Rate(per 1000 female or male adults) in Iraq in 1984 to that in 1985?
Make the answer very short. 1.09. What is the ratio of the Mortality Rate(per 1000 female or male adults) in Slovak Republic in 1984 to that in 1985?
Make the answer very short. 0.95. What is the ratio of the Mortality Rate(per 1000 female or male adults) in Aruba in 1984 to that in 1986?
Ensure brevity in your answer.  1.02. What is the ratio of the Mortality Rate(per 1000 female or male adults) in Iraq in 1984 to that in 1986?
Offer a terse response. 1.19. What is the ratio of the Mortality Rate(per 1000 female or male adults) in Slovak Republic in 1984 to that in 1986?
Ensure brevity in your answer.  0.97. What is the ratio of the Mortality Rate(per 1000 female or male adults) in Aruba in 1985 to that in 1986?
Give a very brief answer. 1.01. What is the ratio of the Mortality Rate(per 1000 female or male adults) in Iraq in 1985 to that in 1986?
Make the answer very short. 1.09. What is the difference between the highest and the second highest Mortality Rate(per 1000 female or male adults) of Aruba?
Give a very brief answer. 1.77. What is the difference between the highest and the second highest Mortality Rate(per 1000 female or male adults) in Iraq?
Your response must be concise. 10.24. What is the difference between the highest and the second highest Mortality Rate(per 1000 female or male adults) in Slovak Republic?
Make the answer very short. 1.31. What is the difference between the highest and the lowest Mortality Rate(per 1000 female or male adults) of Aruba?
Provide a succinct answer. 7.94. What is the difference between the highest and the lowest Mortality Rate(per 1000 female or male adults) of Iraq?
Offer a terse response. 74.74. What is the difference between the highest and the lowest Mortality Rate(per 1000 female or male adults) in Slovak Republic?
Offer a terse response. 6.21. 